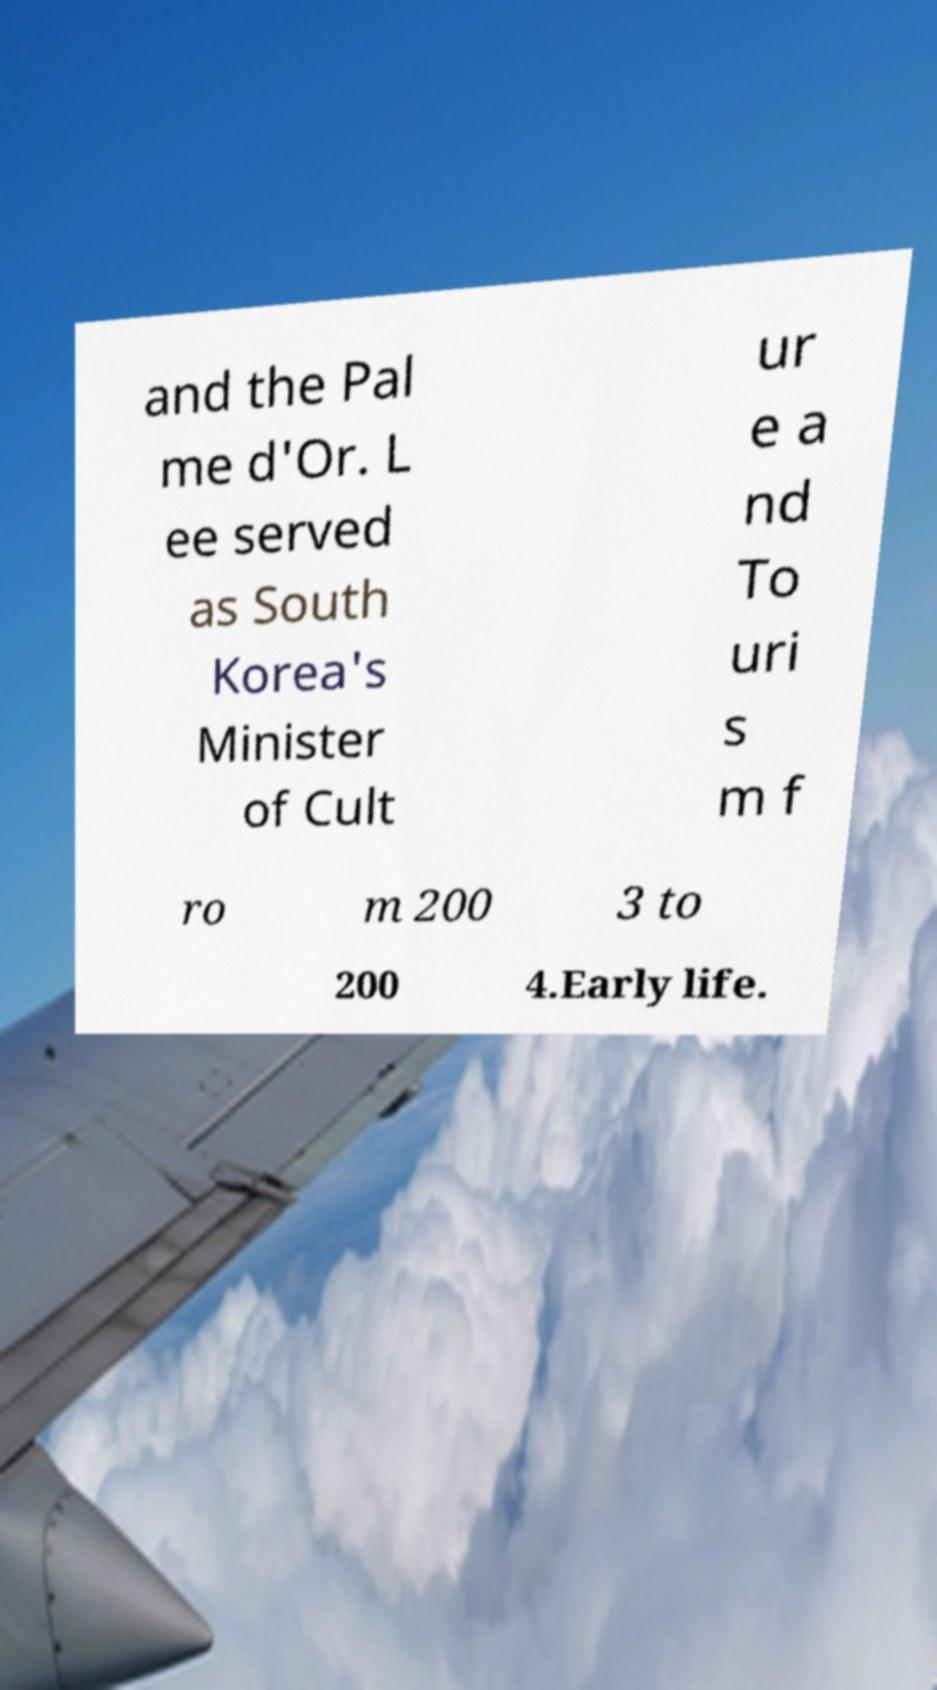For documentation purposes, I need the text within this image transcribed. Could you provide that? and the Pal me d'Or. L ee served as South Korea's Minister of Cult ur e a nd To uri s m f ro m 200 3 to 200 4.Early life. 